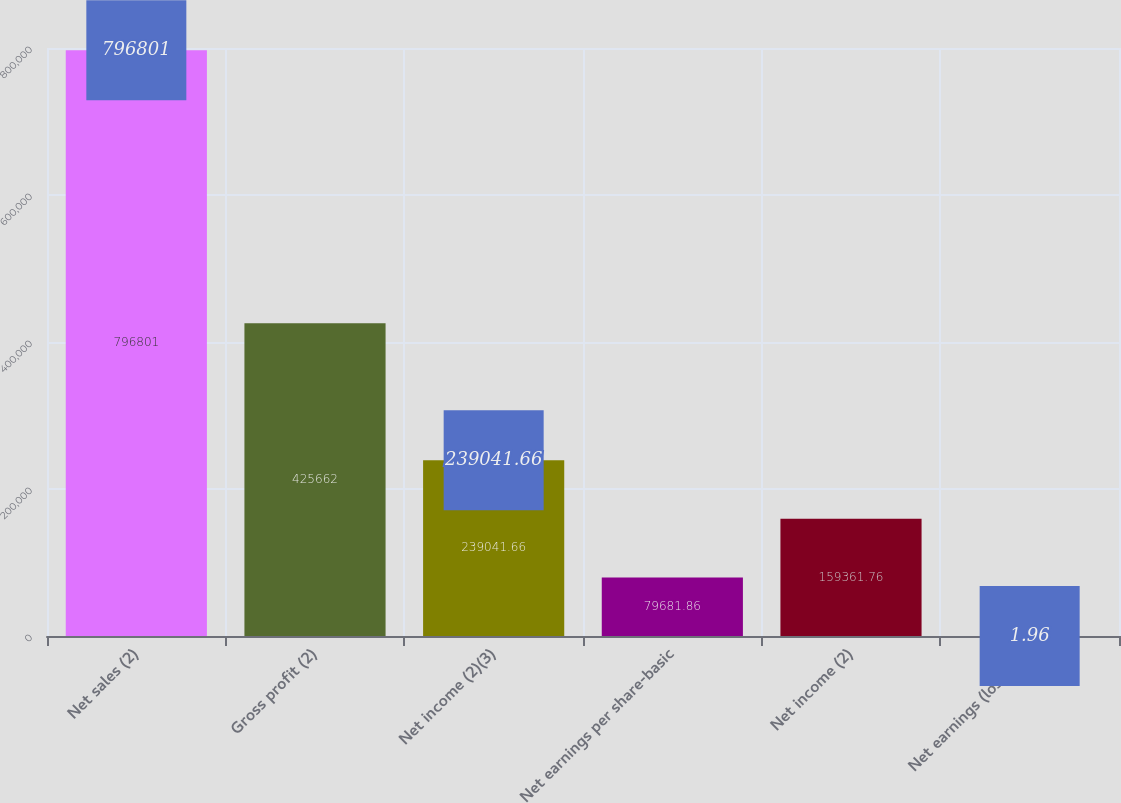Convert chart. <chart><loc_0><loc_0><loc_500><loc_500><bar_chart><fcel>Net sales (2)<fcel>Gross profit (2)<fcel>Net income (2)(3)<fcel>Net earnings per share-basic<fcel>Net income (2)<fcel>Net earnings (loss) per<nl><fcel>796801<fcel>425662<fcel>239042<fcel>79681.9<fcel>159362<fcel>1.96<nl></chart> 